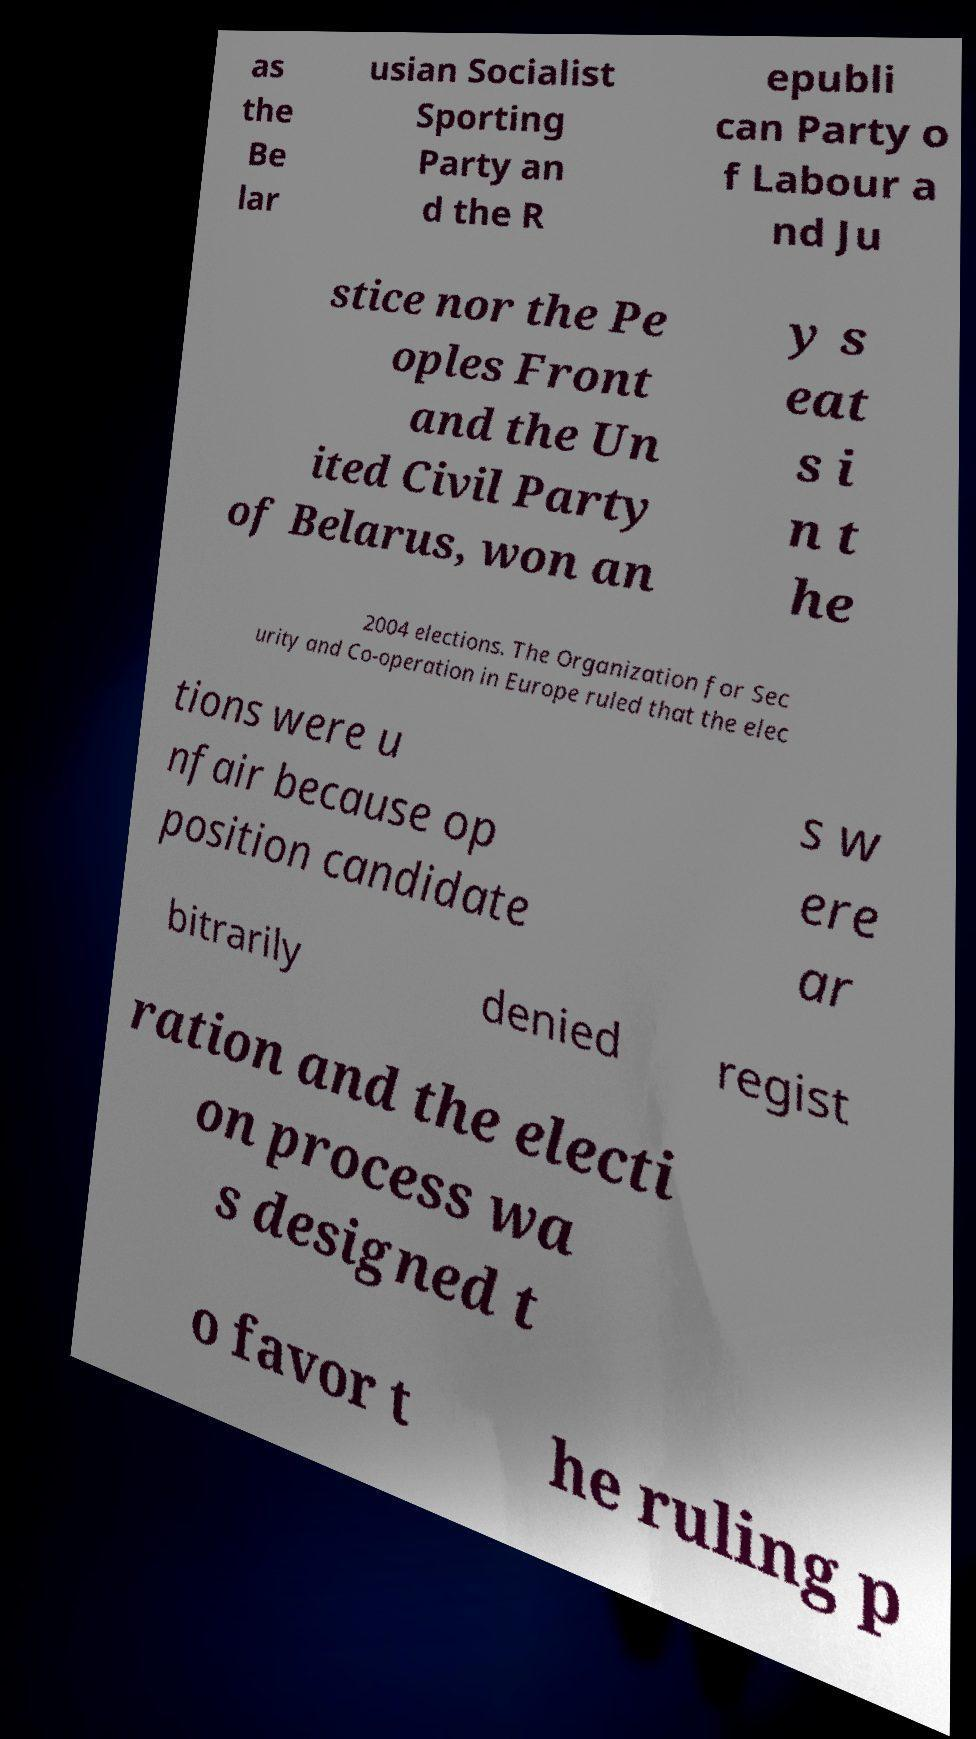For documentation purposes, I need the text within this image transcribed. Could you provide that? as the Be lar usian Socialist Sporting Party an d the R epubli can Party o f Labour a nd Ju stice nor the Pe oples Front and the Un ited Civil Party of Belarus, won an y s eat s i n t he 2004 elections. The Organization for Sec urity and Co-operation in Europe ruled that the elec tions were u nfair because op position candidate s w ere ar bitrarily denied regist ration and the electi on process wa s designed t o favor t he ruling p 